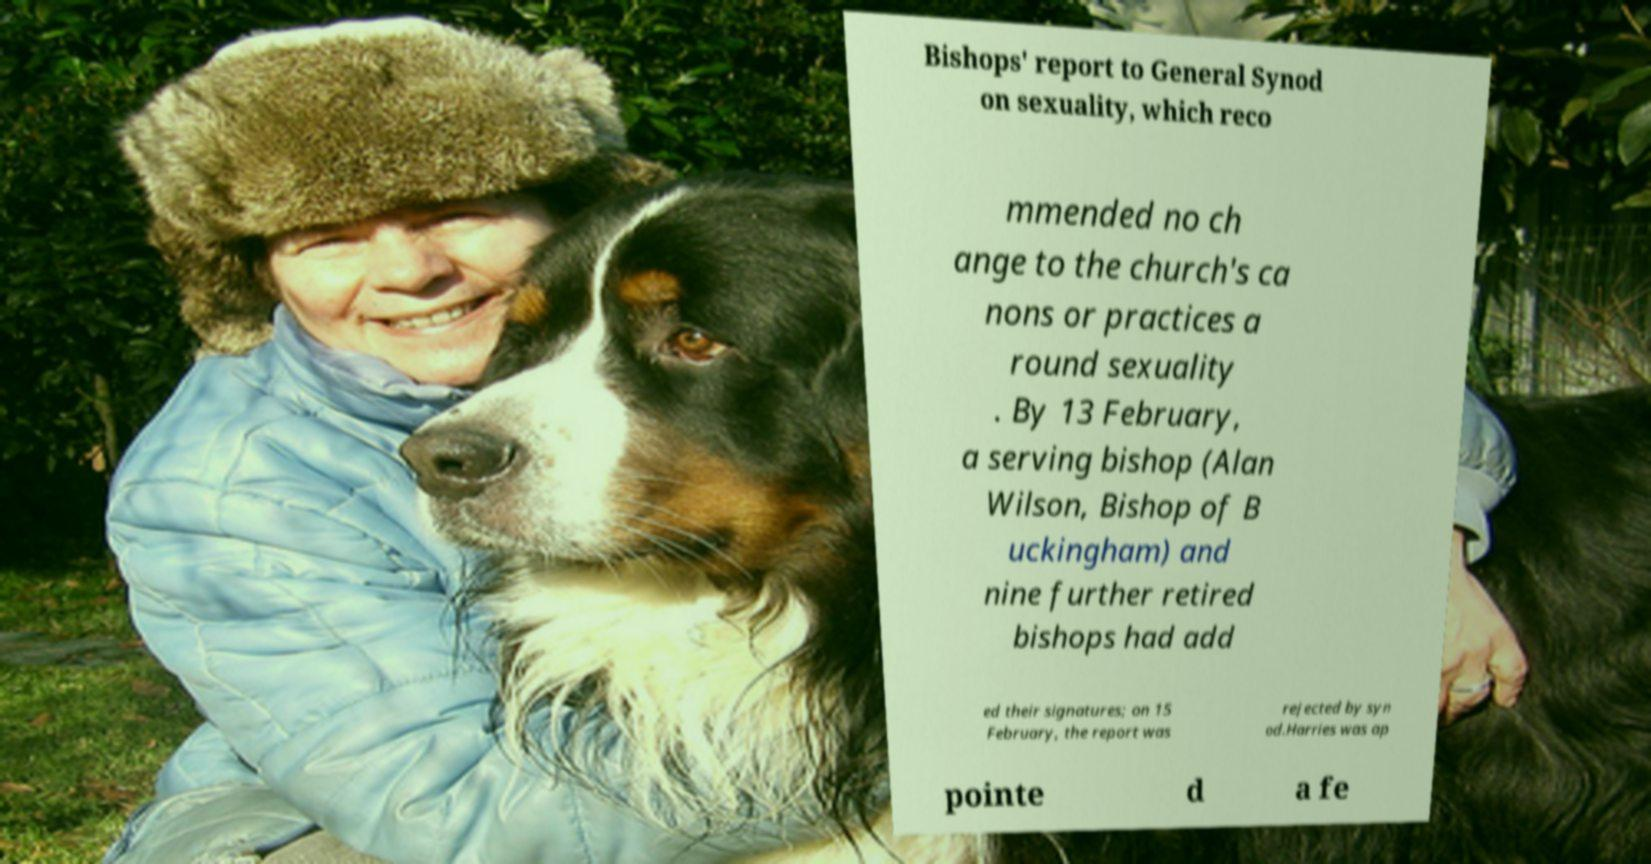Can you accurately transcribe the text from the provided image for me? Bishops' report to General Synod on sexuality, which reco mmended no ch ange to the church's ca nons or practices a round sexuality . By 13 February, a serving bishop (Alan Wilson, Bishop of B uckingham) and nine further retired bishops had add ed their signatures; on 15 February, the report was rejected by syn od.Harries was ap pointe d a fe 